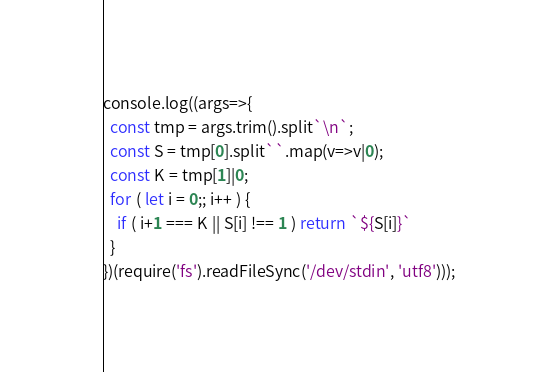Convert code to text. <code><loc_0><loc_0><loc_500><loc_500><_JavaScript_>console.log((args=>{
  const tmp = args.trim().split`\n`;
  const S = tmp[0].split``.map(v=>v|0);
  const K = tmp[1]|0;
  for ( let i = 0;; i++ ) {
    if ( i+1 === K || S[i] !== 1 ) return `${S[i]}`
  }
})(require('fs').readFileSync('/dev/stdin', 'utf8')));
</code> 